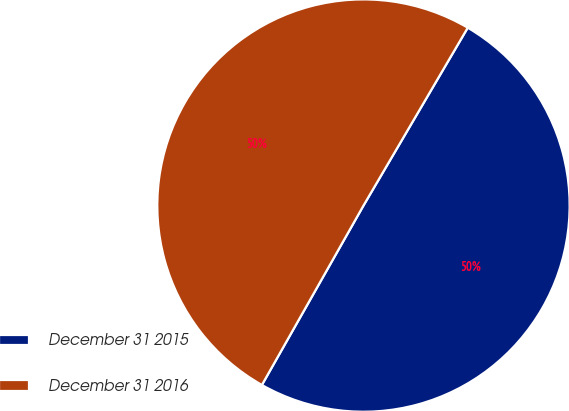<chart> <loc_0><loc_0><loc_500><loc_500><pie_chart><fcel>December 31 2015<fcel>December 31 2016<nl><fcel>49.76%<fcel>50.24%<nl></chart> 